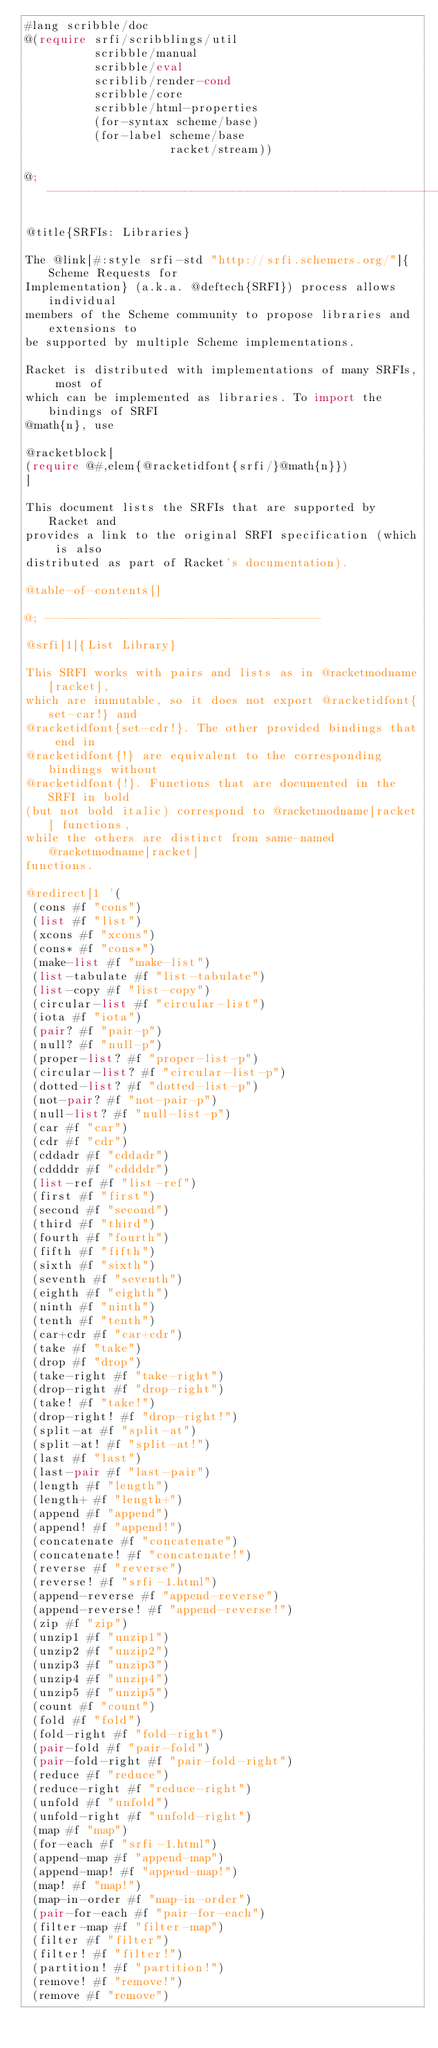<code> <loc_0><loc_0><loc_500><loc_500><_Racket_>#lang scribble/doc
@(require srfi/scribblings/util
          scribble/manual
          scribble/eval
          scriblib/render-cond
          scribble/core
          scribble/html-properties
          (for-syntax scheme/base)
          (for-label scheme/base
                     racket/stream))

@; ----------------------------------------------------------------------

@title{SRFIs: Libraries}

The @link[#:style srfi-std "http://srfi.schemers.org/"]{Scheme Requests for
Implementation} (a.k.a. @deftech{SRFI}) process allows individual
members of the Scheme community to propose libraries and extensions to
be supported by multiple Scheme implementations.

Racket is distributed with implementations of many SRFIs, most of
which can be implemented as libraries. To import the bindings of SRFI
@math{n}, use

@racketblock[
(require @#,elem{@racketidfont{srfi/}@math{n}})
]

This document lists the SRFIs that are supported by Racket and
provides a link to the original SRFI specification (which is also
distributed as part of Racket's documentation).

@table-of-contents[]

@; ----------------------------------------

@srfi[1]{List Library}

This SRFI works with pairs and lists as in @racketmodname[racket],
which are immutable, so it does not export @racketidfont{set-car!} and
@racketidfont{set-cdr!}. The other provided bindings that end in
@racketidfont{!} are equivalent to the corresponding bindings without
@racketidfont{!}. Functions that are documented in the SRFI in bold
(but not bold italic) correspond to @racketmodname[racket] functions,
while the others are distinct from same-named @racketmodname[racket]
functions.

@redirect[1 '(
 (cons #f "cons")
 (list #f "list")
 (xcons #f "xcons")
 (cons* #f "cons*")
 (make-list #f "make-list")
 (list-tabulate #f "list-tabulate")
 (list-copy #f "list-copy")
 (circular-list #f "circular-list")
 (iota #f "iota")
 (pair? #f "pair-p")
 (null? #f "null-p")
 (proper-list? #f "proper-list-p")
 (circular-list? #f "circular-list-p")
 (dotted-list? #f "dotted-list-p")
 (not-pair? #f "not-pair-p")
 (null-list? #f "null-list-p")
 (car #f "car")
 (cdr #f "cdr")
 (cddadr #f "cddadr")
 (cddddr #f "cddddr")
 (list-ref #f "list-ref")
 (first #f "first")
 (second #f "second")
 (third #f "third")
 (fourth #f "fourth")
 (fifth #f "fifth")
 (sixth #f "sixth")
 (seventh #f "seventh")
 (eighth #f "eighth")
 (ninth #f "ninth")
 (tenth #f "tenth")
 (car+cdr #f "car+cdr")
 (take #f "take")
 (drop #f "drop")
 (take-right #f "take-right")
 (drop-right #f "drop-right")
 (take! #f "take!")
 (drop-right! #f "drop-right!")
 (split-at #f "split-at")
 (split-at! #f "split-at!")
 (last #f "last")
 (last-pair #f "last-pair")
 (length #f "length")
 (length+ #f "length+")
 (append #f "append")
 (append! #f "append!")
 (concatenate #f "concatenate")
 (concatenate! #f "concatenate!")
 (reverse #f "reverse")
 (reverse! #f "srfi-1.html")
 (append-reverse #f "append-reverse")
 (append-reverse! #f "append-reverse!")
 (zip #f "zip")
 (unzip1 #f "unzip1")
 (unzip2 #f "unzip2")
 (unzip3 #f "unzip3")
 (unzip4 #f "unzip4")
 (unzip5 #f "unzip5")
 (count #f "count")
 (fold #f "fold")
 (fold-right #f "fold-right")
 (pair-fold #f "pair-fold")
 (pair-fold-right #f "pair-fold-right")
 (reduce #f "reduce")
 (reduce-right #f "reduce-right")
 (unfold #f "unfold")
 (unfold-right #f "unfold-right")
 (map #f "map")
 (for-each #f "srfi-1.html")
 (append-map #f "append-map")
 (append-map! #f "append-map!")
 (map! #f "map!")
 (map-in-order #f "map-in-order")
 (pair-for-each #f "pair-for-each")
 (filter-map #f "filter-map")
 (filter #f "filter")
 (filter! #f "filter!")
 (partition! #f "partition!")
 (remove! #f "remove!")
 (remove #f "remove")</code> 